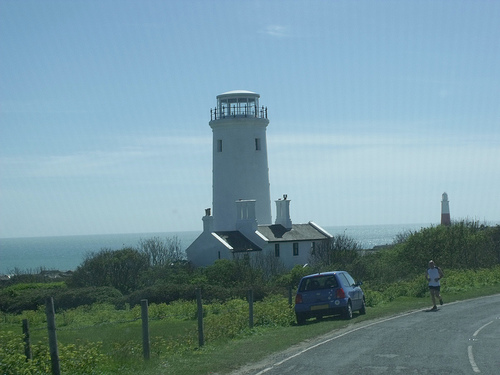<image>
Can you confirm if the lighthouse is to the left of the man? Yes. From this viewpoint, the lighthouse is positioned to the left side relative to the man. Is the car in front of the building? Yes. The car is positioned in front of the building, appearing closer to the camera viewpoint. 